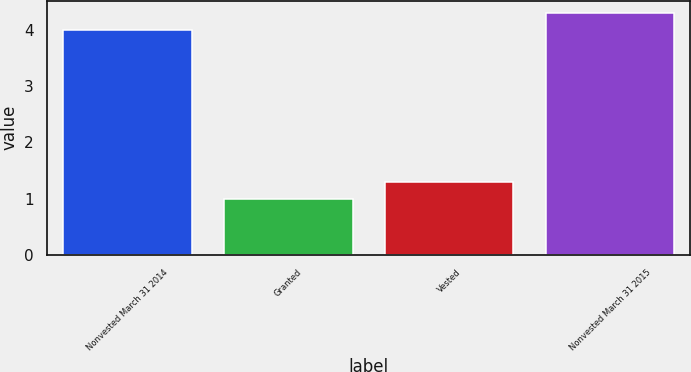Convert chart to OTSL. <chart><loc_0><loc_0><loc_500><loc_500><bar_chart><fcel>Nonvested March 31 2014<fcel>Granted<fcel>Vested<fcel>Nonvested March 31 2015<nl><fcel>4<fcel>1<fcel>1.3<fcel>4.3<nl></chart> 